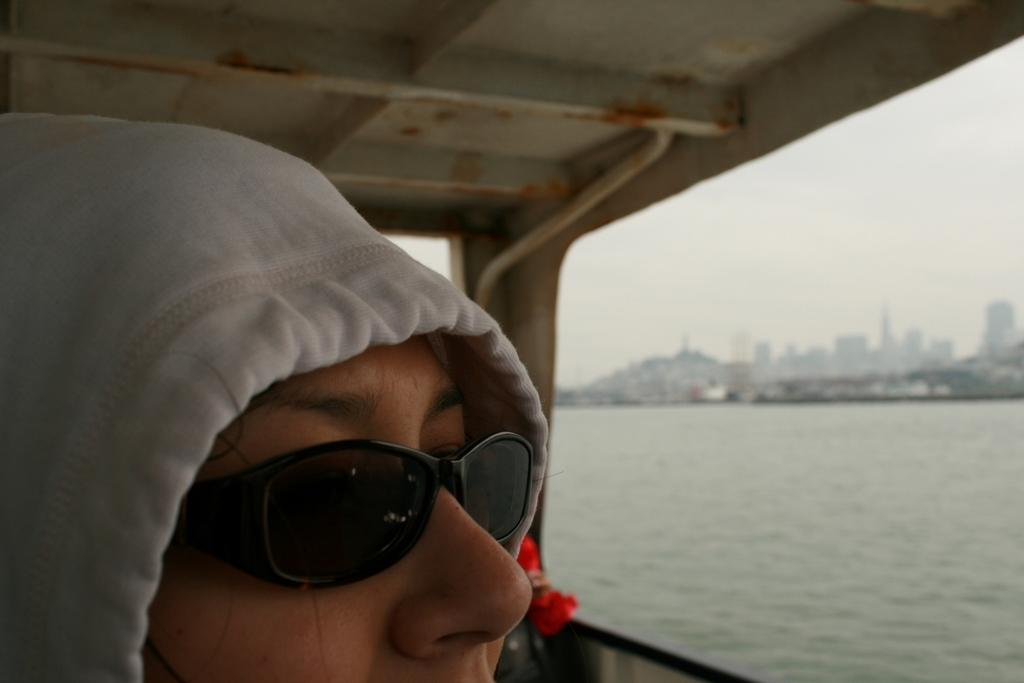Who is present on the left side of the image? There is a person on the left side of the image. What can be observed about the person's appearance? The person is wearing spectacles. What can be seen in the background of the image? Water and buildings are visible in the background of the image. What type of bait is being used to catch the pigs in the image? There are no pigs or bait present in the image. Can you describe the house in the image? There is no house present in the image. 